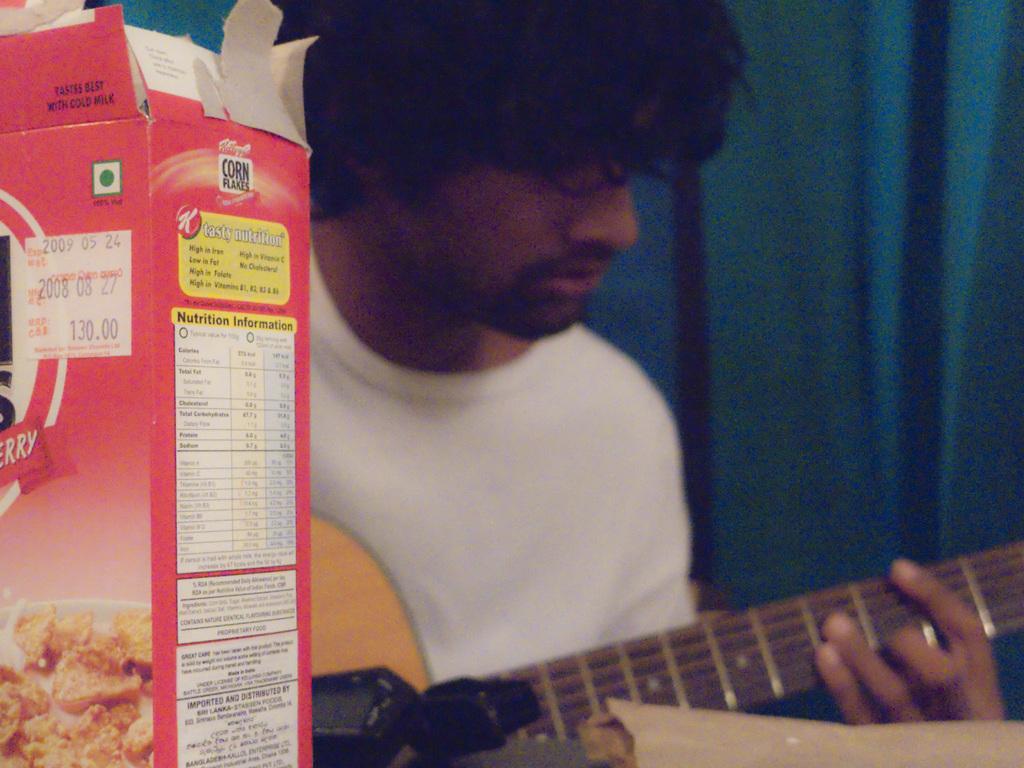Can you describe this image briefly? In this picture we can see a man holding a guitar and beside there is a corn flakes box. 